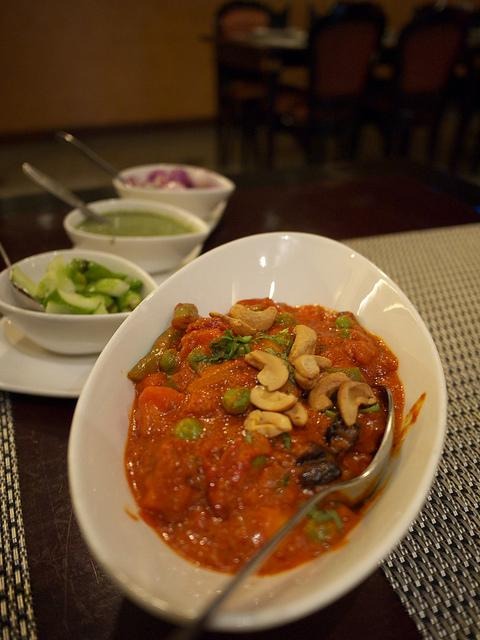What fungal growth is visible here? Please explain your reasoning. mushrooms. The other options are fruit and vegetables. 